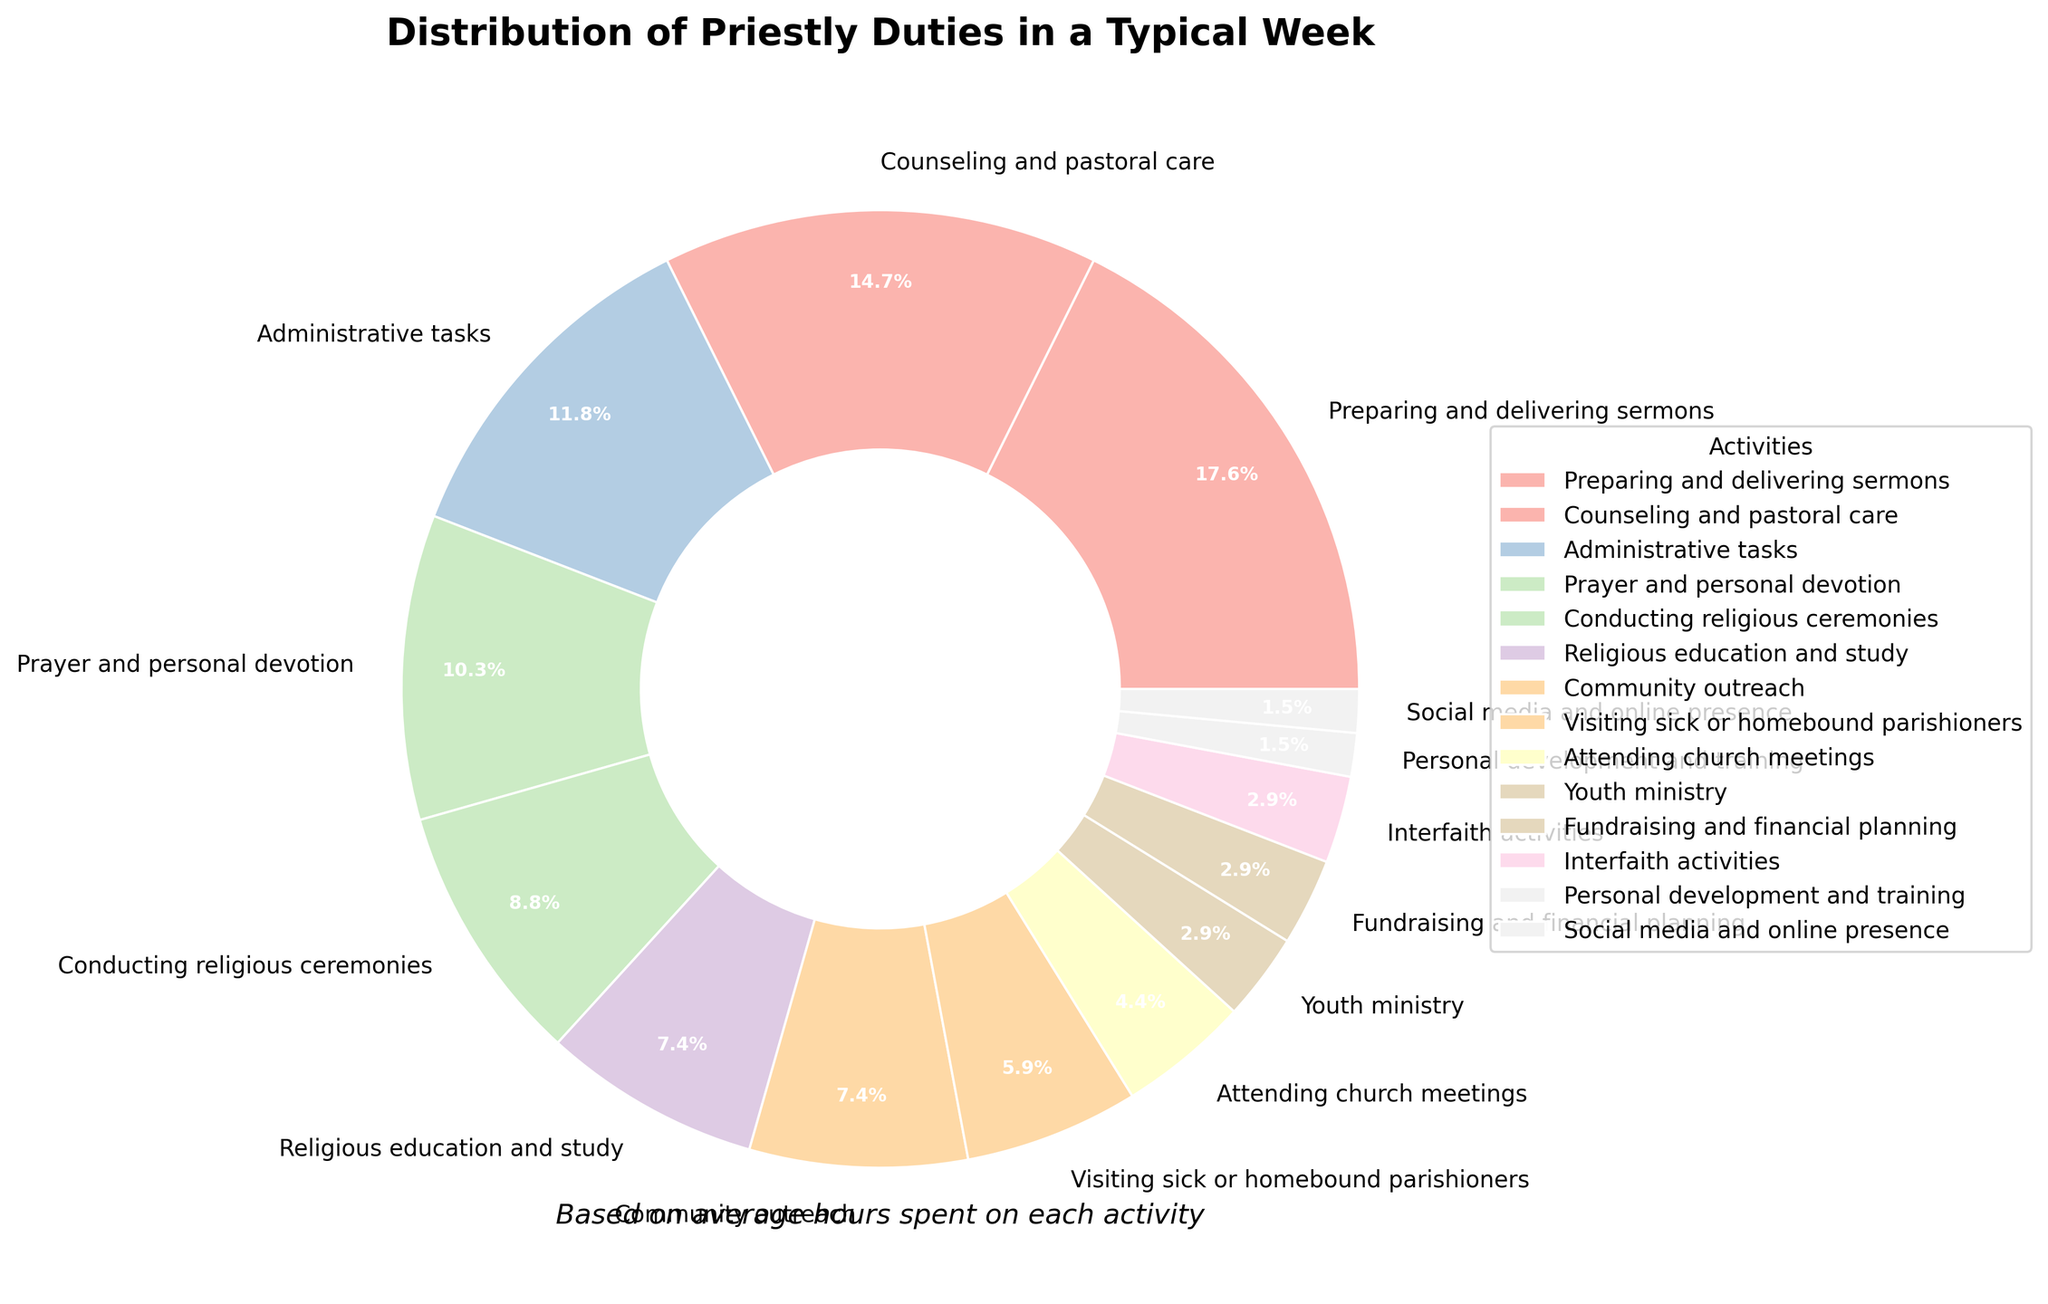Which activity takes up the most time for priests in a typical week? By looking at the size of each wedge in the pie chart, the "Preparing and delivering sermons" section is the largest. This indicates it takes up the most time.
Answer: Preparing and delivering sermons How much more time do priests spend on counseling and pastoral care compared to interfaith activities? From the pie chart, "Counseling and pastoral care" occupies 10 hours, while "Interfaith activities" occupies 2 hours. The difference is 10 - 2 = 8 hours.
Answer: 8 hours What percentage of the week is spent on administrative tasks? From the pie chart, the "Administrative tasks" section shows a percentage label. The percentage is displayed as 9.5%.
Answer: 9.5% Are there more hours dedicated to youths ministry than to attending church meetings? By comparing the wedges in the pie chart, "Attending church meetings" takes up 3 hours and "Youth ministry" takes up 2 hours. 3 is more than 2.
Answer: No What's the combined percentage of time spent on personal development and training, and social media and online presence? The percentages for "Personal development and training" and "Social media and online presence" are 1.2% each. Combining these, 1.2% + 1.2% = 2.4%.
Answer: 2.4% How much longer do priests spend on visiting sick or homebound parishioners than on fundraising and financial planning? From the pie chart, the time spent on "Visiting sick or homebound parishioners" is 4 hours, and on "Fundraising and financial planning" is 2 hours. The difference is 4 - 2 = 2 hours.
Answer: 2 hours Which activity takes less time than conducting religious ceremonies but more time than youth ministry? The pie chart shows "Conducting religious ceremonies" occupies 6 hours, and "Youth ministry" occupies 2 hours. The activity "Religious education and study" takes up 5 hours, which fits in between.
Answer: Religious education and study How many total hours are spent on community outreach and religious education and study combined? According to the pie chart, "Community outreach" takes 5 hours, and "Religious education and study" takes 5 hours as well. The total is 5 + 5 = 10 hours.
Answer: 10 hours What proportion of time is allocated to prayer and personal devotion relative to youth ministry? "Prayer and personal devotion" occupy 7 hours, while "Youth ministry" takes 2 hours. The relative proportion is calculated by dividing 7 by 2, yielding 7/2 = 3.5 times.
Answer: 3.5 times 